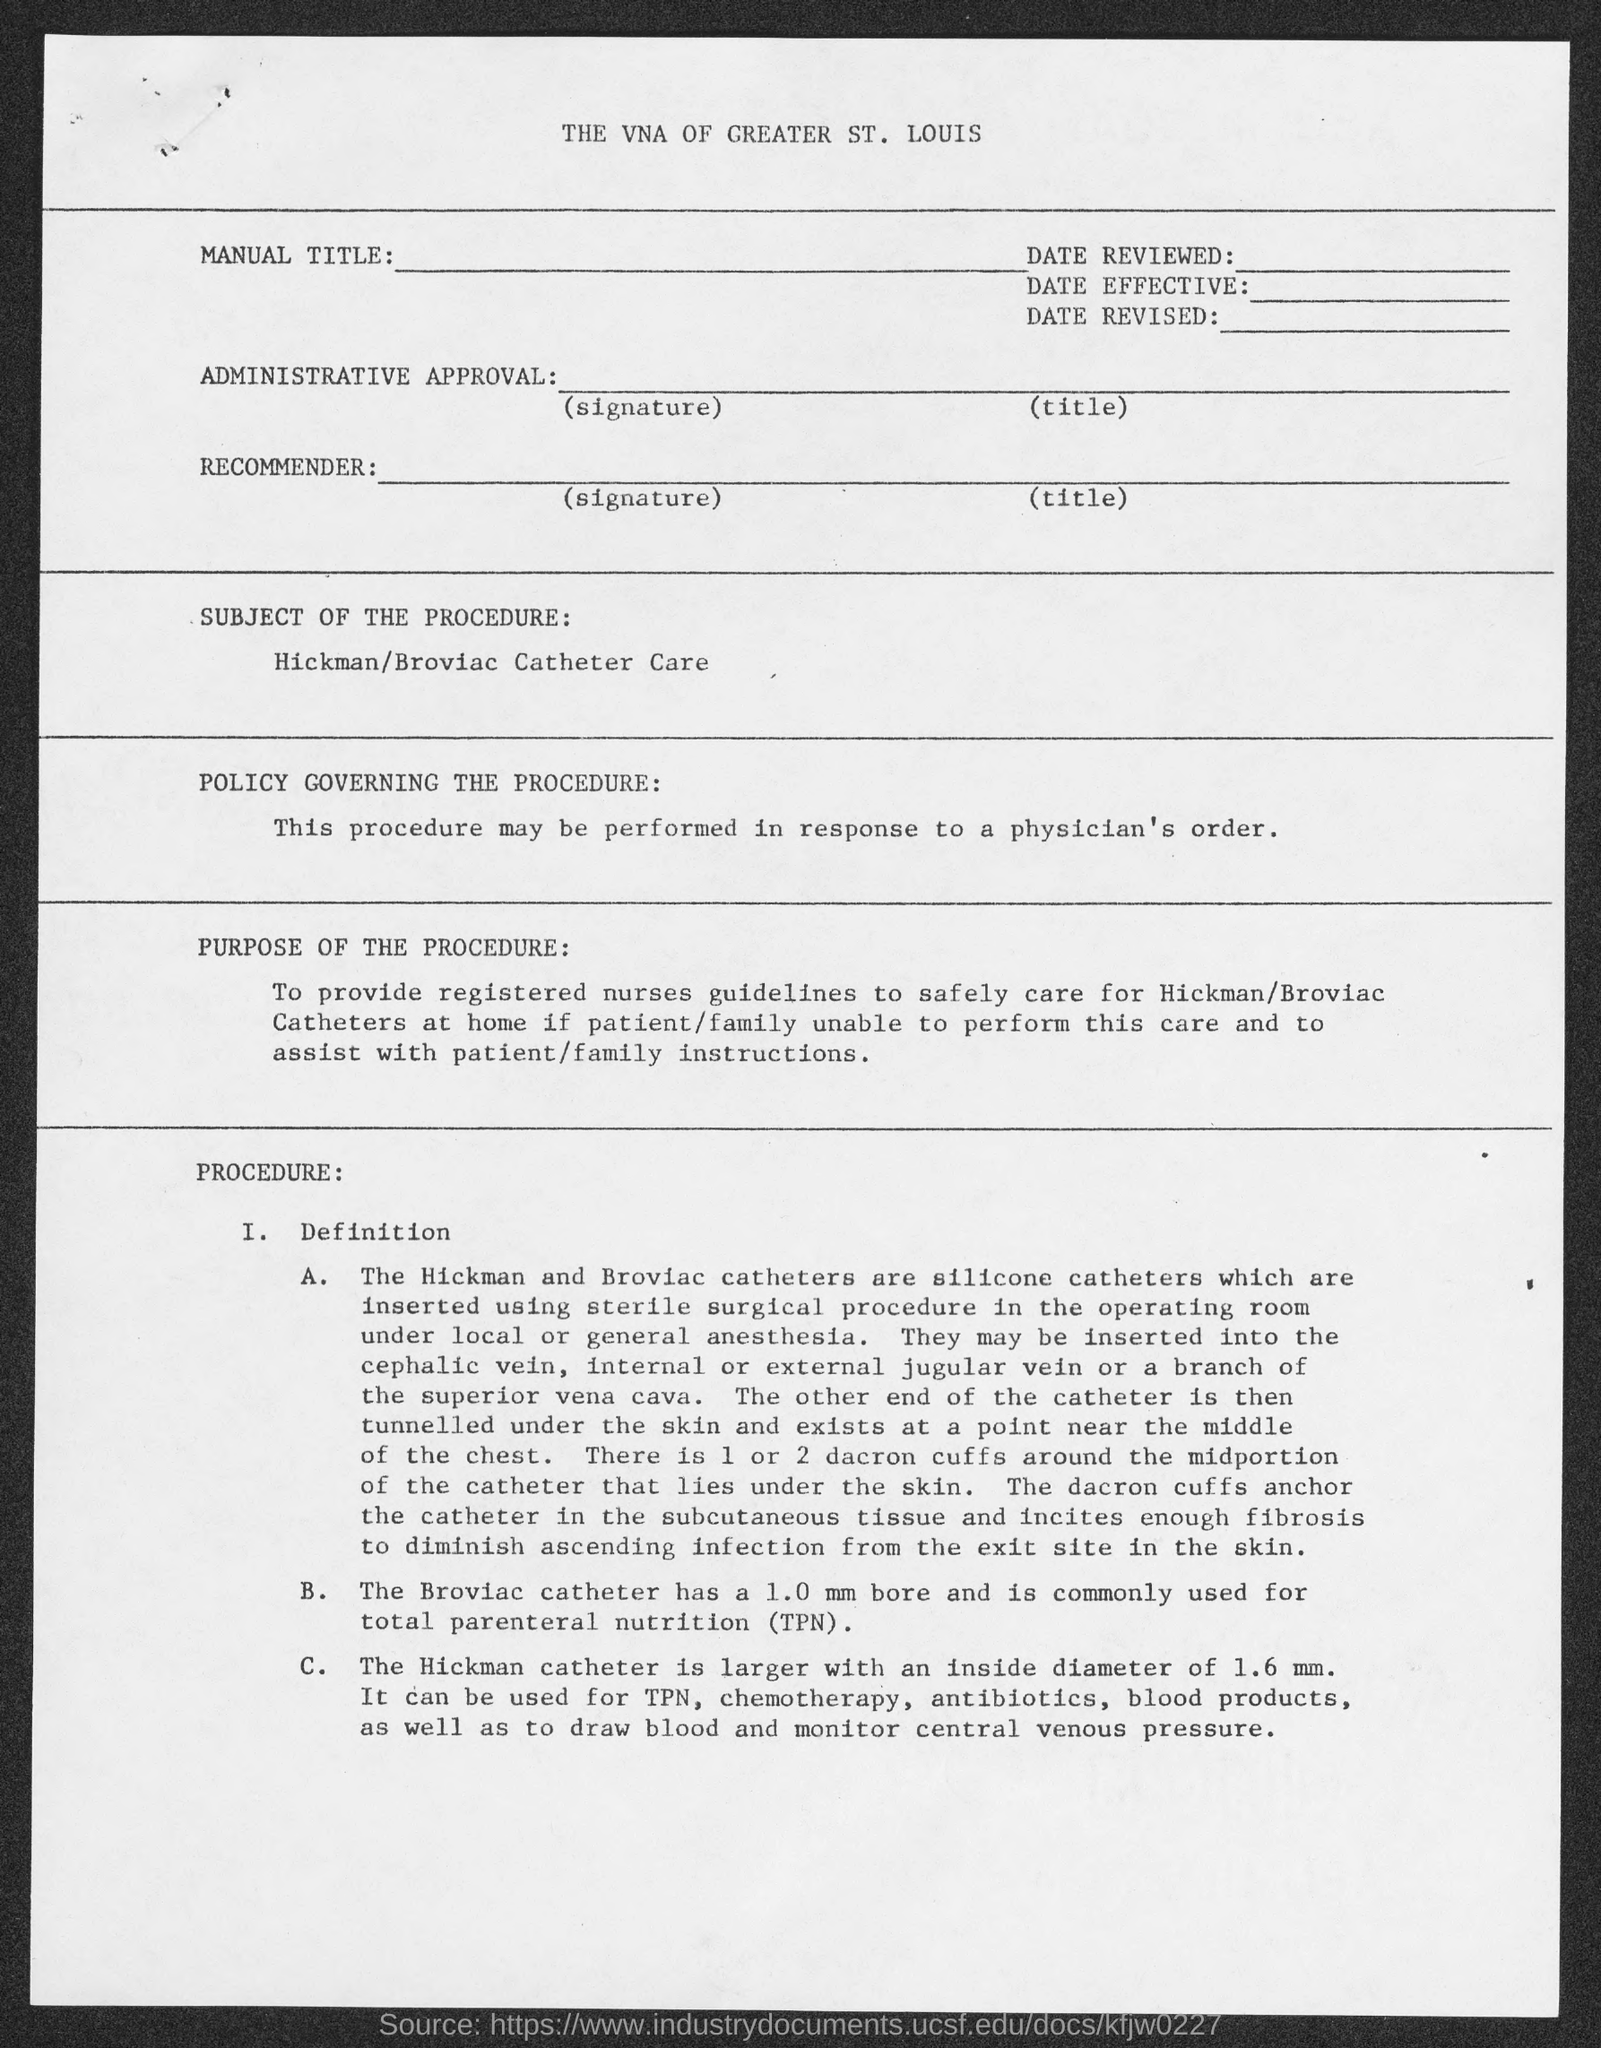What is the Broviac Catheter commonly used for?
Ensure brevity in your answer.  TOTAL PARENTERAL NUTRITION (TPN). What is the subject of the procedure?
Offer a terse response. HICKMAN/BROVIAC CATHETER CARE. 